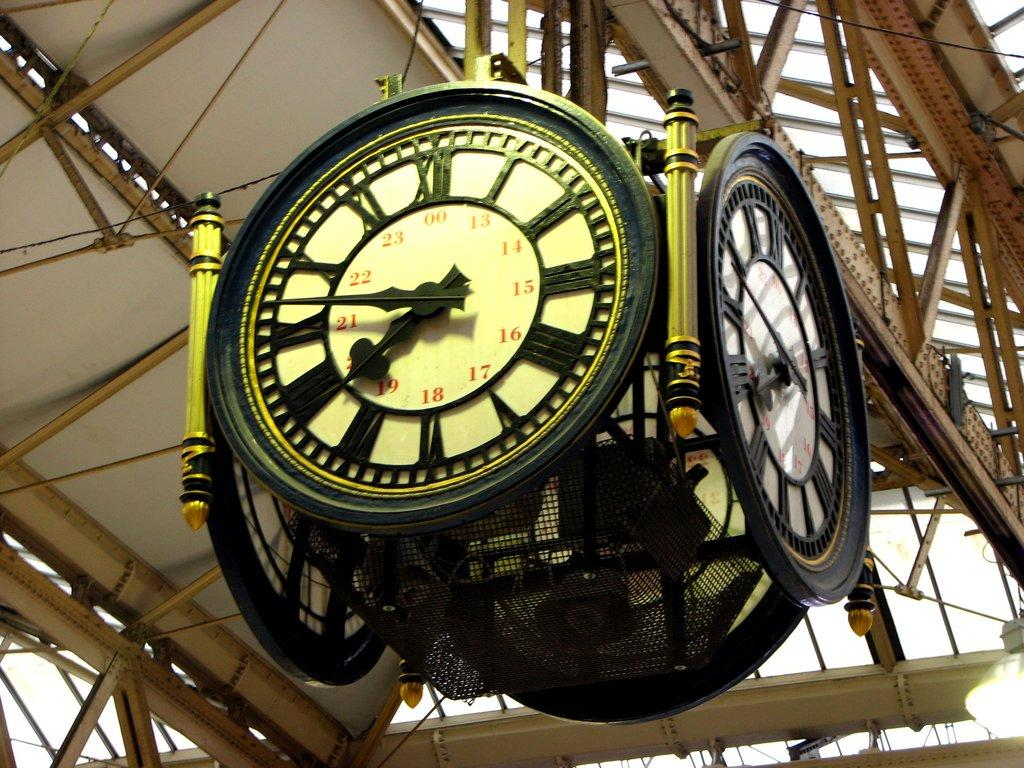What objects are located at the top of the image? There are clocks at the top of the image. What structures can be seen in the image? There are stands in the image. How would you describe the weather in the image? The sky is cloudy in the image. How many cubs are playing with the frogs in the image? There are no cubs or frogs present in the image. What color are the cherries hanging from the stands in the image? There are no cherries present in the image. 